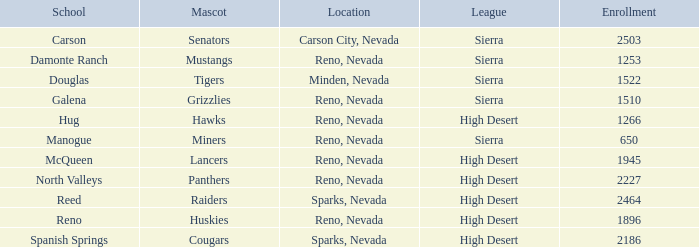What city and state are the miners located in? Reno, Nevada. 